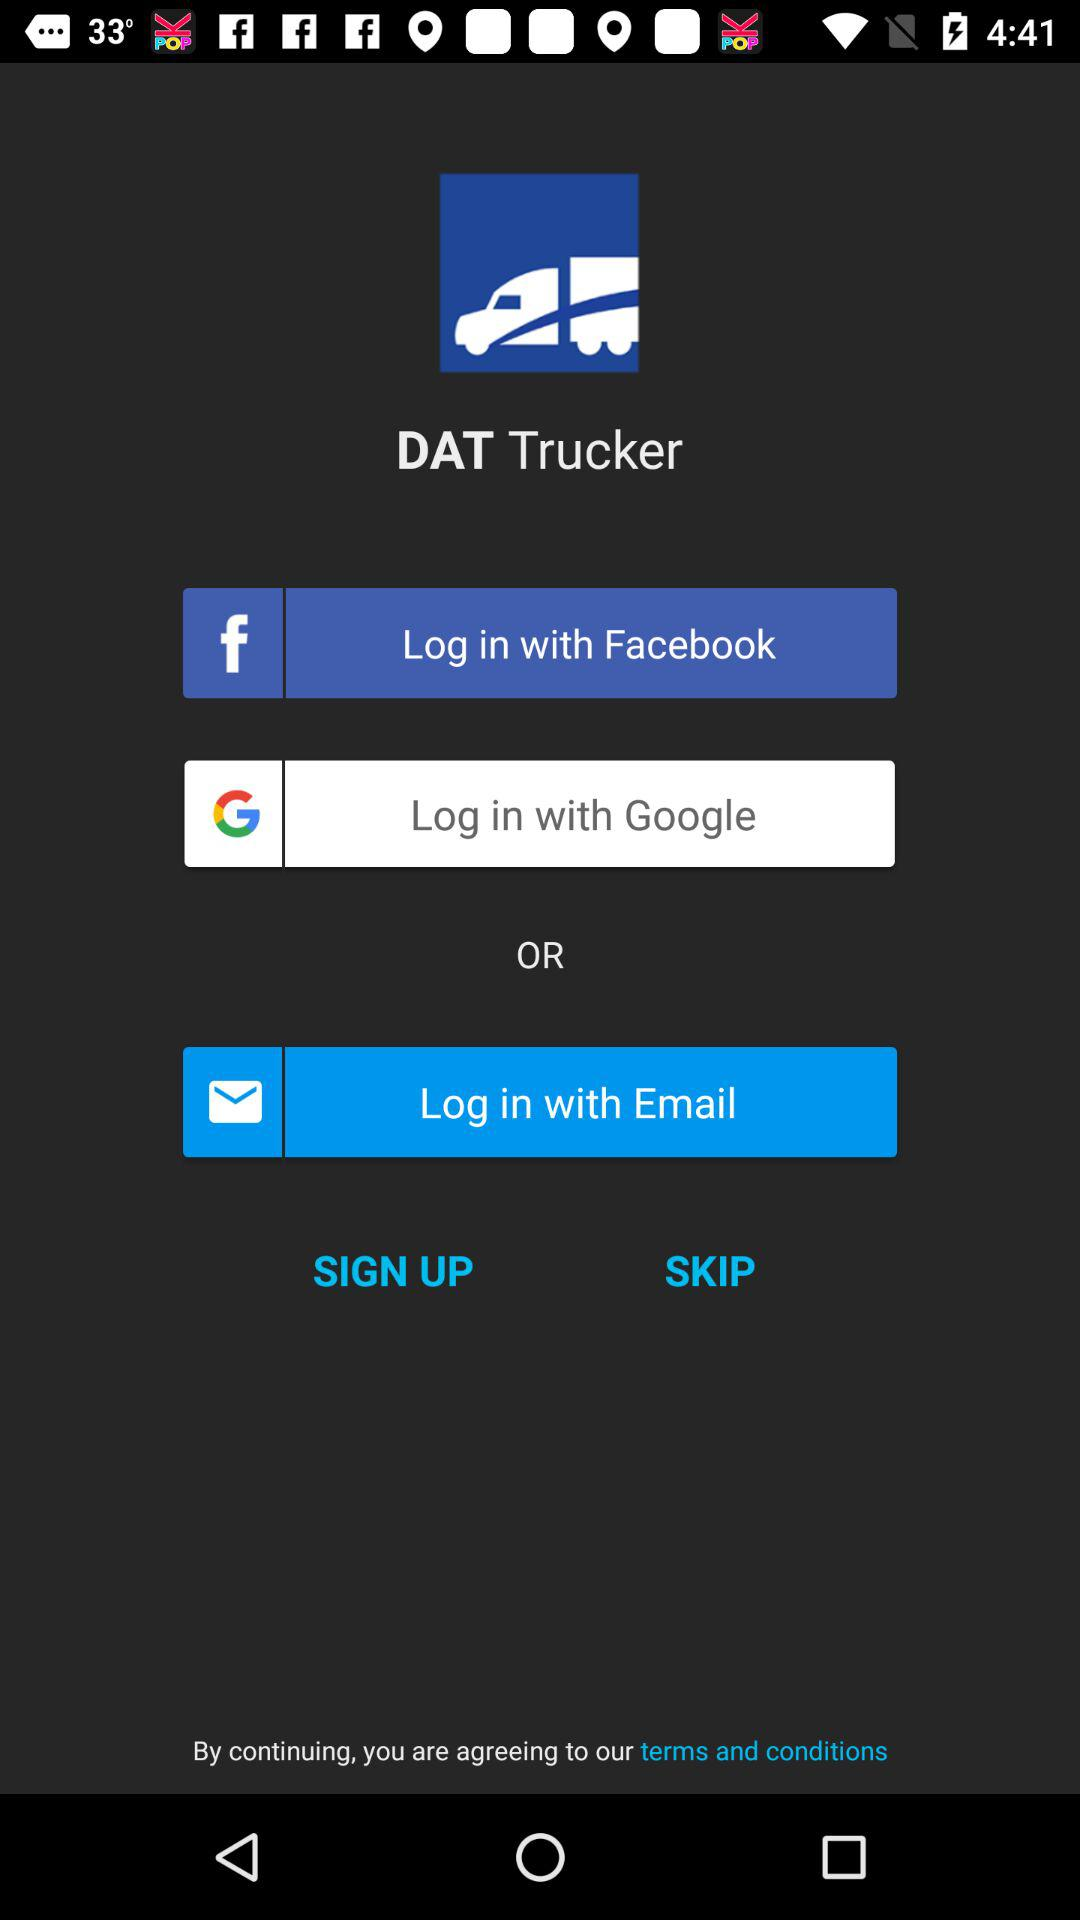How many login options are there?
Answer the question using a single word or phrase. 3 